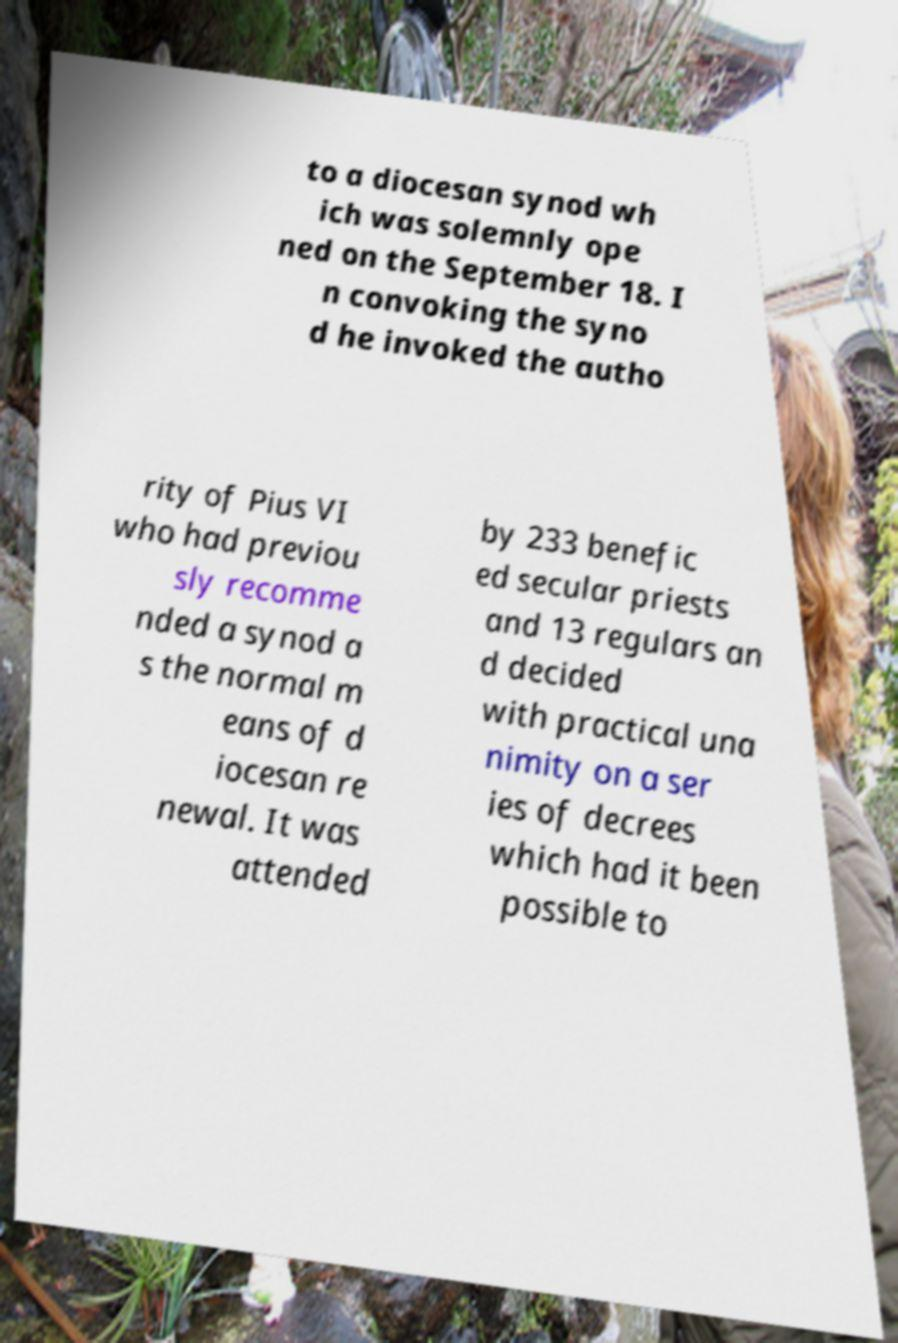I need the written content from this picture converted into text. Can you do that? to a diocesan synod wh ich was solemnly ope ned on the September 18. I n convoking the syno d he invoked the autho rity of Pius VI who had previou sly recomme nded a synod a s the normal m eans of d iocesan re newal. It was attended by 233 benefic ed secular priests and 13 regulars an d decided with practical una nimity on a ser ies of decrees which had it been possible to 